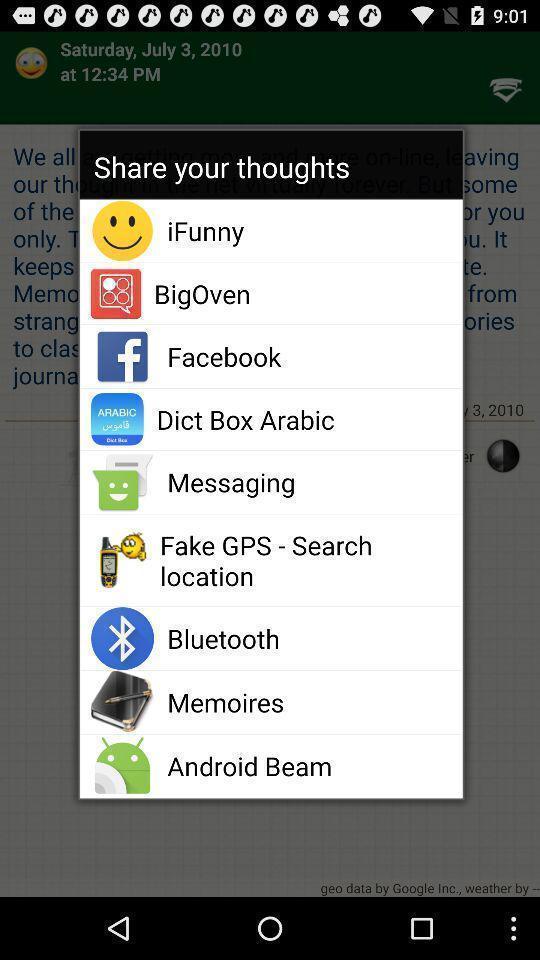What details can you identify in this image? Popup showing different options to share thoughts on an app. 